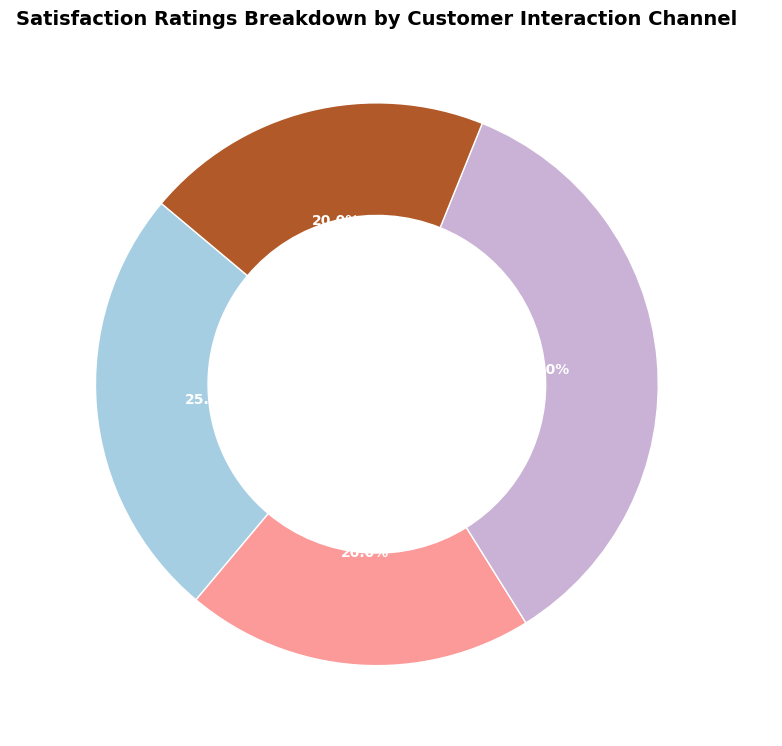What percentage of satisfaction ratings were received via Live Chat? Look at the slice labeled "Live Chat" and read the percentage value.
Answer: 35% Which two customer interaction channels have the same satisfaction rating? Examine each labeled slice for percentages. Both Email and Social Media slices show the same value.
Answer: Email and Social Media What is the total percentage of satisfaction ratings from both Phone and Email channels? Add the percentages from the Phone and Email slices: 25% (Phone) + 20% (Email) = 45%.
Answer: 45% Which channel has received the highest satisfaction rating? Identify the slice with the largest percentage value. In this case, it’s Live Chat with 35%.
Answer: Live Chat How much higher is the satisfaction rating for Live Chat compared to Social Media? Subtract the percentage value of Social Media from Live Chat: 35% (Live Chat) - 20% (Social Media) = 15%.
Answer: 15% Rank the channels from highest to lowest satisfaction rating. Identify the percentages of all slices and order them: Live Chat (35%), Phone (25%), Email (20%), Social Media (20%).
Answer: Live Chat, Phone, Email, Social Media What is the combined percentage of satisfaction ratings from digital channels (Live Chat, Email, and Social Media)? Add the percentages of Live Chat, Email, and Social Media: 35% (Live Chat) + 20% (Email) + 20% (Social Media) = 75%.
Answer: 75% If the satisfaction rating for Phone were to increase by 5%, would it surpass the highest current satisfaction rating, and by how much? Add 5% to the Phone rating: 25% + 5% = 30%. Compare 30% with 35% for Live Chat. No, it would still be 5% lower.
Answer: No, 5% lower What is the average satisfaction rating across all channels? Sum all percentage values and divide by the number of channels: (25% + 20% + 35% + 20%) / 4 = 100% / 4 = 25%.
Answer: 25% Which channels constitute exactly 40% of the satisfaction ratings when combined? Sum different combinations until reaching the target value: Phone (25%) + Email (20%) = 45%. Email (20%) + Social Media (20%) = 40%.
Answer: Email and Social Media 